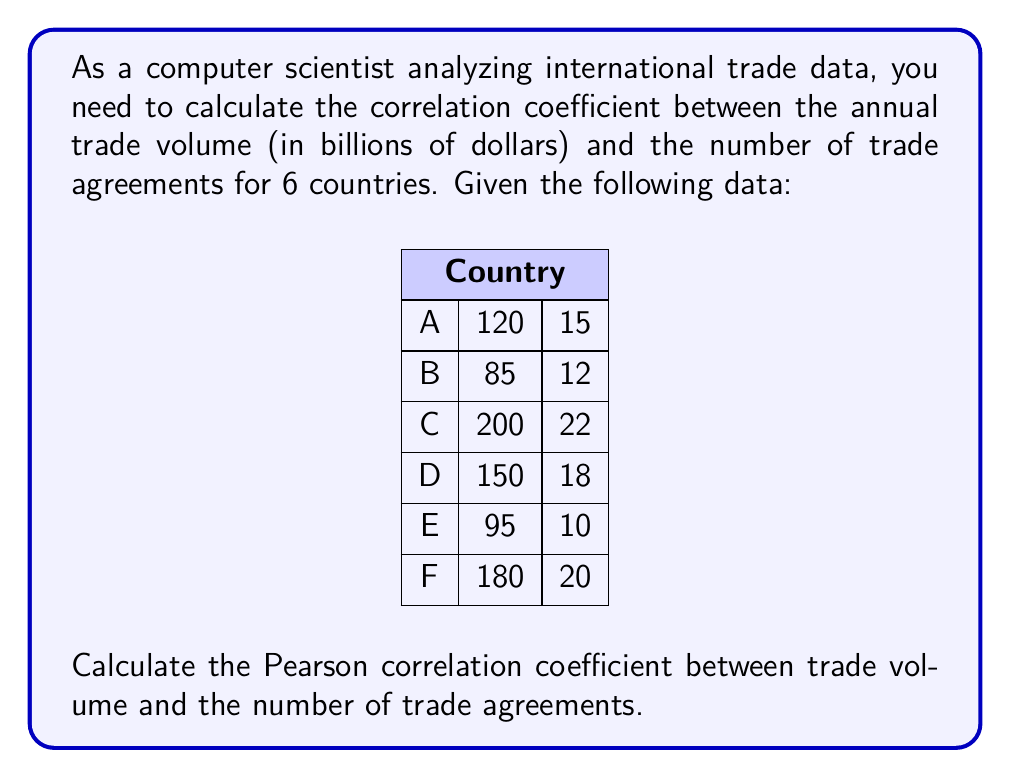Could you help me with this problem? To calculate the Pearson correlation coefficient, we'll follow these steps:

1. Calculate the means of both variables:
   $\bar{x} = \frac{120 + 85 + 200 + 150 + 95 + 180}{6} = 138.33$
   $\bar{y} = \frac{15 + 12 + 22 + 18 + 10 + 20}{6} = 16.17$

2. Calculate the deviations from the mean for each variable:
   $x_i - \bar{x}$ and $y_i - \bar{y}$

3. Calculate the products of the deviations:
   $(x_i - \bar{x})(y_i - \bar{y})$

4. Sum the products of deviations:
   $\sum (x_i - \bar{x})(y_i - \bar{y})$

5. Calculate the sum of squared deviations for each variable:
   $\sum (x_i - \bar{x})^2$ and $\sum (y_i - \bar{y})^2$

6. Apply the formula for Pearson correlation coefficient:

   $r = \frac{\sum (x_i - \bar{x})(y_i - \bar{y})}{\sqrt{\sum (x_i - \bar{x})^2 \sum (y_i - \bar{y})^2}}$

Let's calculate:

$\sum (x_i - \bar{x})(y_i - \bar{y}) = 638.89$
$\sum (x_i - \bar{x})^2 = 13,888.89$
$\sum (y_i - \bar{y})^2 = 102.83$

Now, we can plug these values into the formula:

$r = \frac{638.89}{\sqrt{13,888.89 \times 102.83}} = \frac{638.89}{1,194.87} = 0.5347$
Answer: $r \approx 0.5347$ 